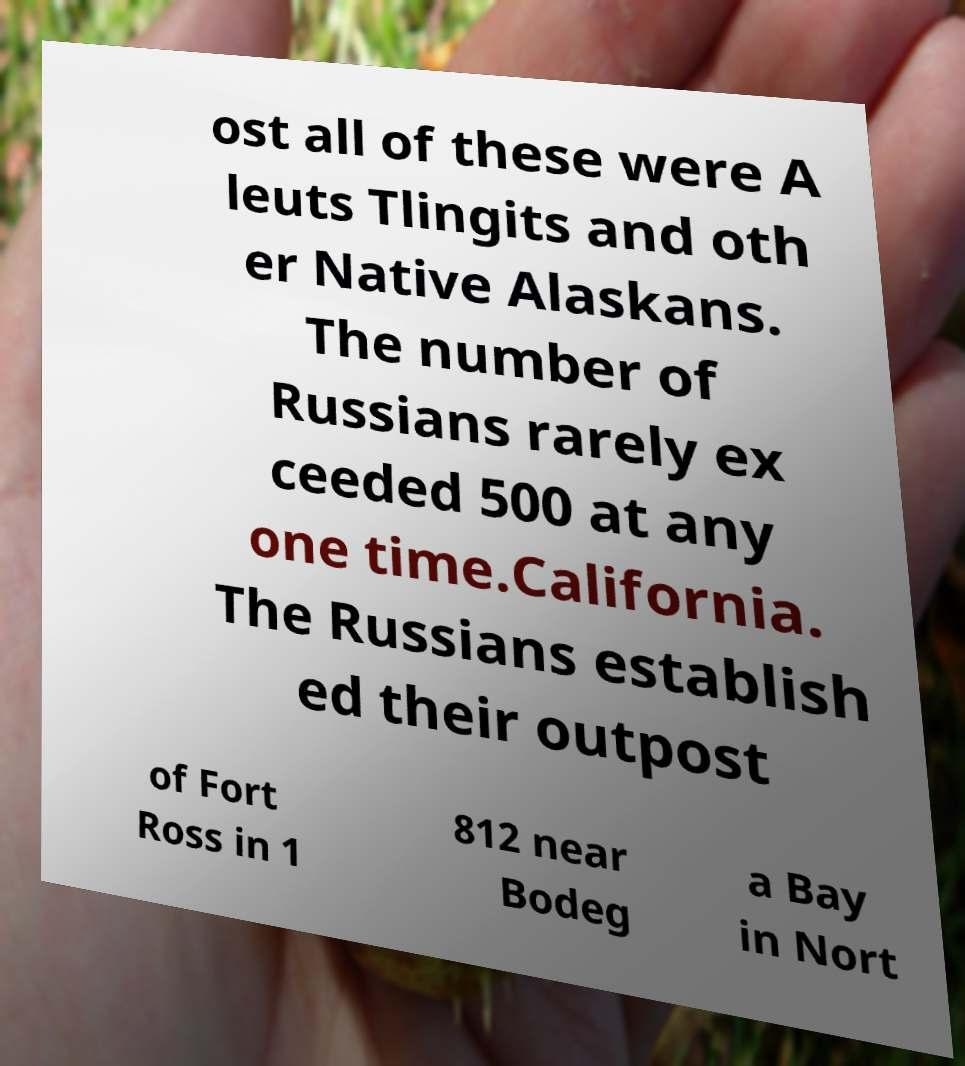Please read and relay the text visible in this image. What does it say? ost all of these were A leuts Tlingits and oth er Native Alaskans. The number of Russians rarely ex ceeded 500 at any one time.California. The Russians establish ed their outpost of Fort Ross in 1 812 near Bodeg a Bay in Nort 